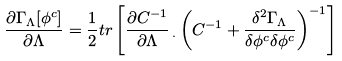<formula> <loc_0><loc_0><loc_500><loc_500>\frac { \partial \Gamma _ { \Lambda } [ \phi ^ { c } ] } { \partial \Lambda } = \frac { 1 } { 2 } t r \left [ \frac { \partial C ^ { - 1 } } { \partial \Lambda } \, _ { . } \left ( C ^ { - 1 } + \frac { \delta ^ { 2 } \Gamma _ { \Lambda } } { \delta \phi ^ { c } \delta \phi ^ { c } } \right ) ^ { - 1 } \right ]</formula> 